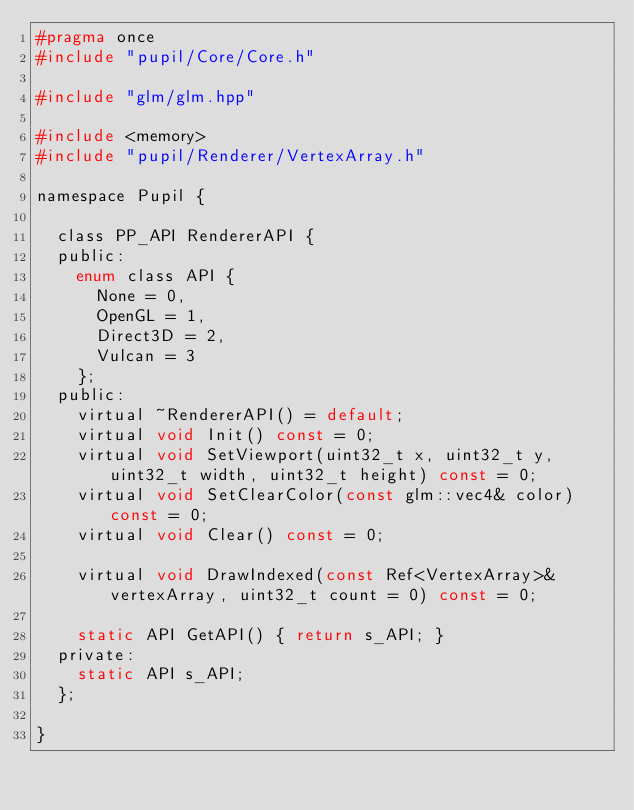Convert code to text. <code><loc_0><loc_0><loc_500><loc_500><_C_>#pragma once
#include "pupil/Core/Core.h"

#include "glm/glm.hpp"

#include <memory>
#include "pupil/Renderer/VertexArray.h"

namespace Pupil {

	class PP_API RendererAPI {
	public:
		enum class API {
			None = 0,
			OpenGL = 1,
			Direct3D = 2,
			Vulcan = 3
		};
	public:
		virtual ~RendererAPI() = default;
		virtual void Init() const = 0;
		virtual void SetViewport(uint32_t x, uint32_t y, uint32_t width, uint32_t height) const = 0;
		virtual void SetClearColor(const glm::vec4& color) const = 0;
		virtual void Clear() const = 0;

		virtual void DrawIndexed(const Ref<VertexArray>& vertexArray, uint32_t count = 0) const = 0;

		static API GetAPI() { return s_API; }
	private:
		static API s_API;
	};

}</code> 